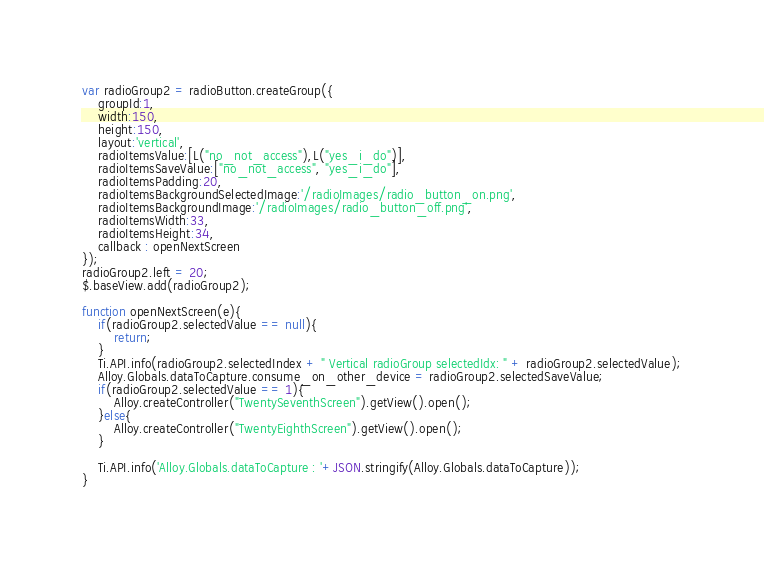Convert code to text. <code><loc_0><loc_0><loc_500><loc_500><_JavaScript_>
var radioGroup2 = radioButton.createGroup({
	groupId:1,
	width:150,
	height:150,
	layout:'vertical',
	radioItemsValue:[L("no_not_access"),L("yes_i_do")],
	radioItemsSaveValue:["no_not_access", "yes_i_do"],
	radioItemsPadding:20,
	radioItemsBackgroundSelectedImage:'/radioImages/radio_button_on.png',
	radioItemsBackgroundImage:'/radioImages/radio_button_off.png',
	radioItemsWidth:33,
	radioItemsHeight:34,
	callback : openNextScreen
});
radioGroup2.left = 20;
$.baseView.add(radioGroup2);

function openNextScreen(e){
	if(radioGroup2.selectedValue == null){
		return;
	}
	Ti.API.info(radioGroup2.selectedIndex + " Vertical radioGroup selectedIdx: " + radioGroup2.selectedValue);
	Alloy.Globals.dataToCapture.consume_on_other_device = radioGroup2.selectedSaveValue;
	if(radioGroup2.selectedValue == 1){
		Alloy.createController("TwentySeventhScreen").getView().open();
	}else{
		Alloy.createController("TwentyEighthScreen").getView().open();
	}
	
	Ti.API.info('Alloy.Globals.dataToCapture : '+JSON.stringify(Alloy.Globals.dataToCapture));
}
</code> 